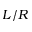<formula> <loc_0><loc_0><loc_500><loc_500>L / R</formula> 